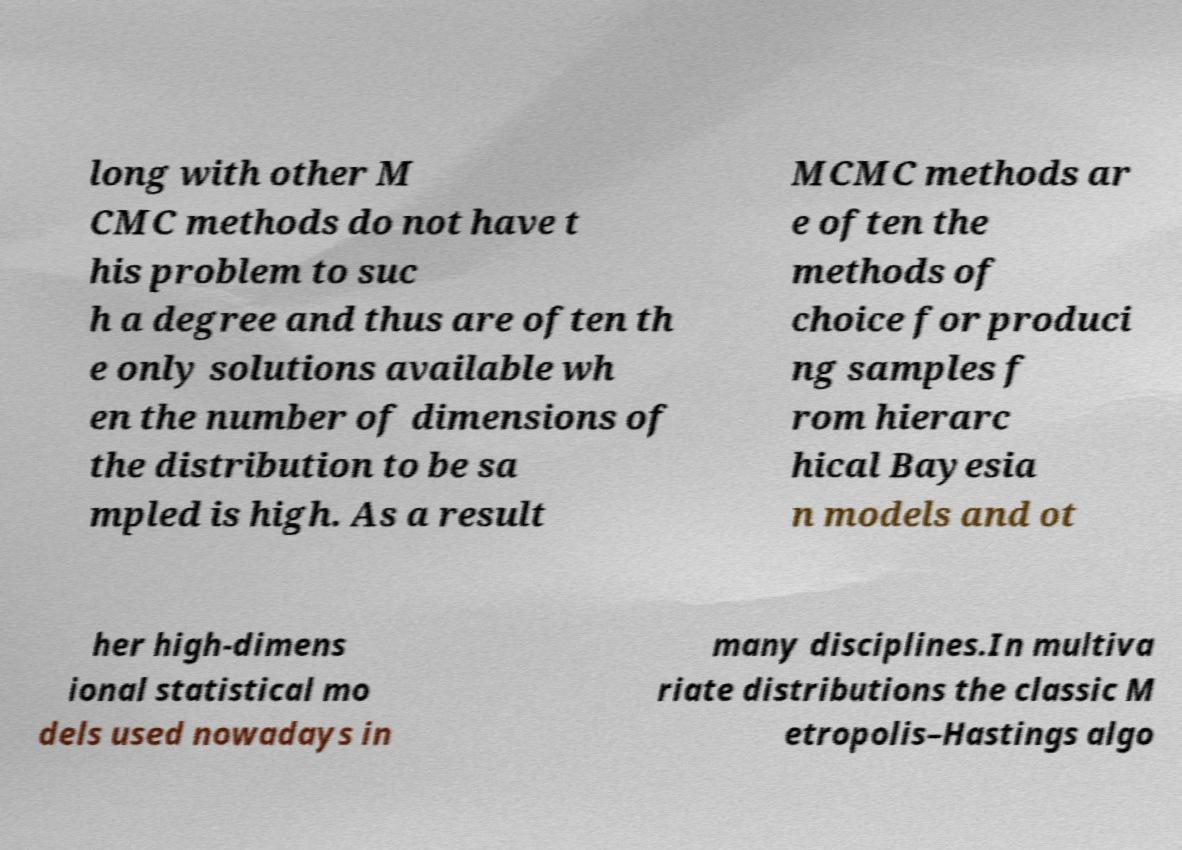Can you read and provide the text displayed in the image?This photo seems to have some interesting text. Can you extract and type it out for me? long with other M CMC methods do not have t his problem to suc h a degree and thus are often th e only solutions available wh en the number of dimensions of the distribution to be sa mpled is high. As a result MCMC methods ar e often the methods of choice for produci ng samples f rom hierarc hical Bayesia n models and ot her high-dimens ional statistical mo dels used nowadays in many disciplines.In multiva riate distributions the classic M etropolis–Hastings algo 